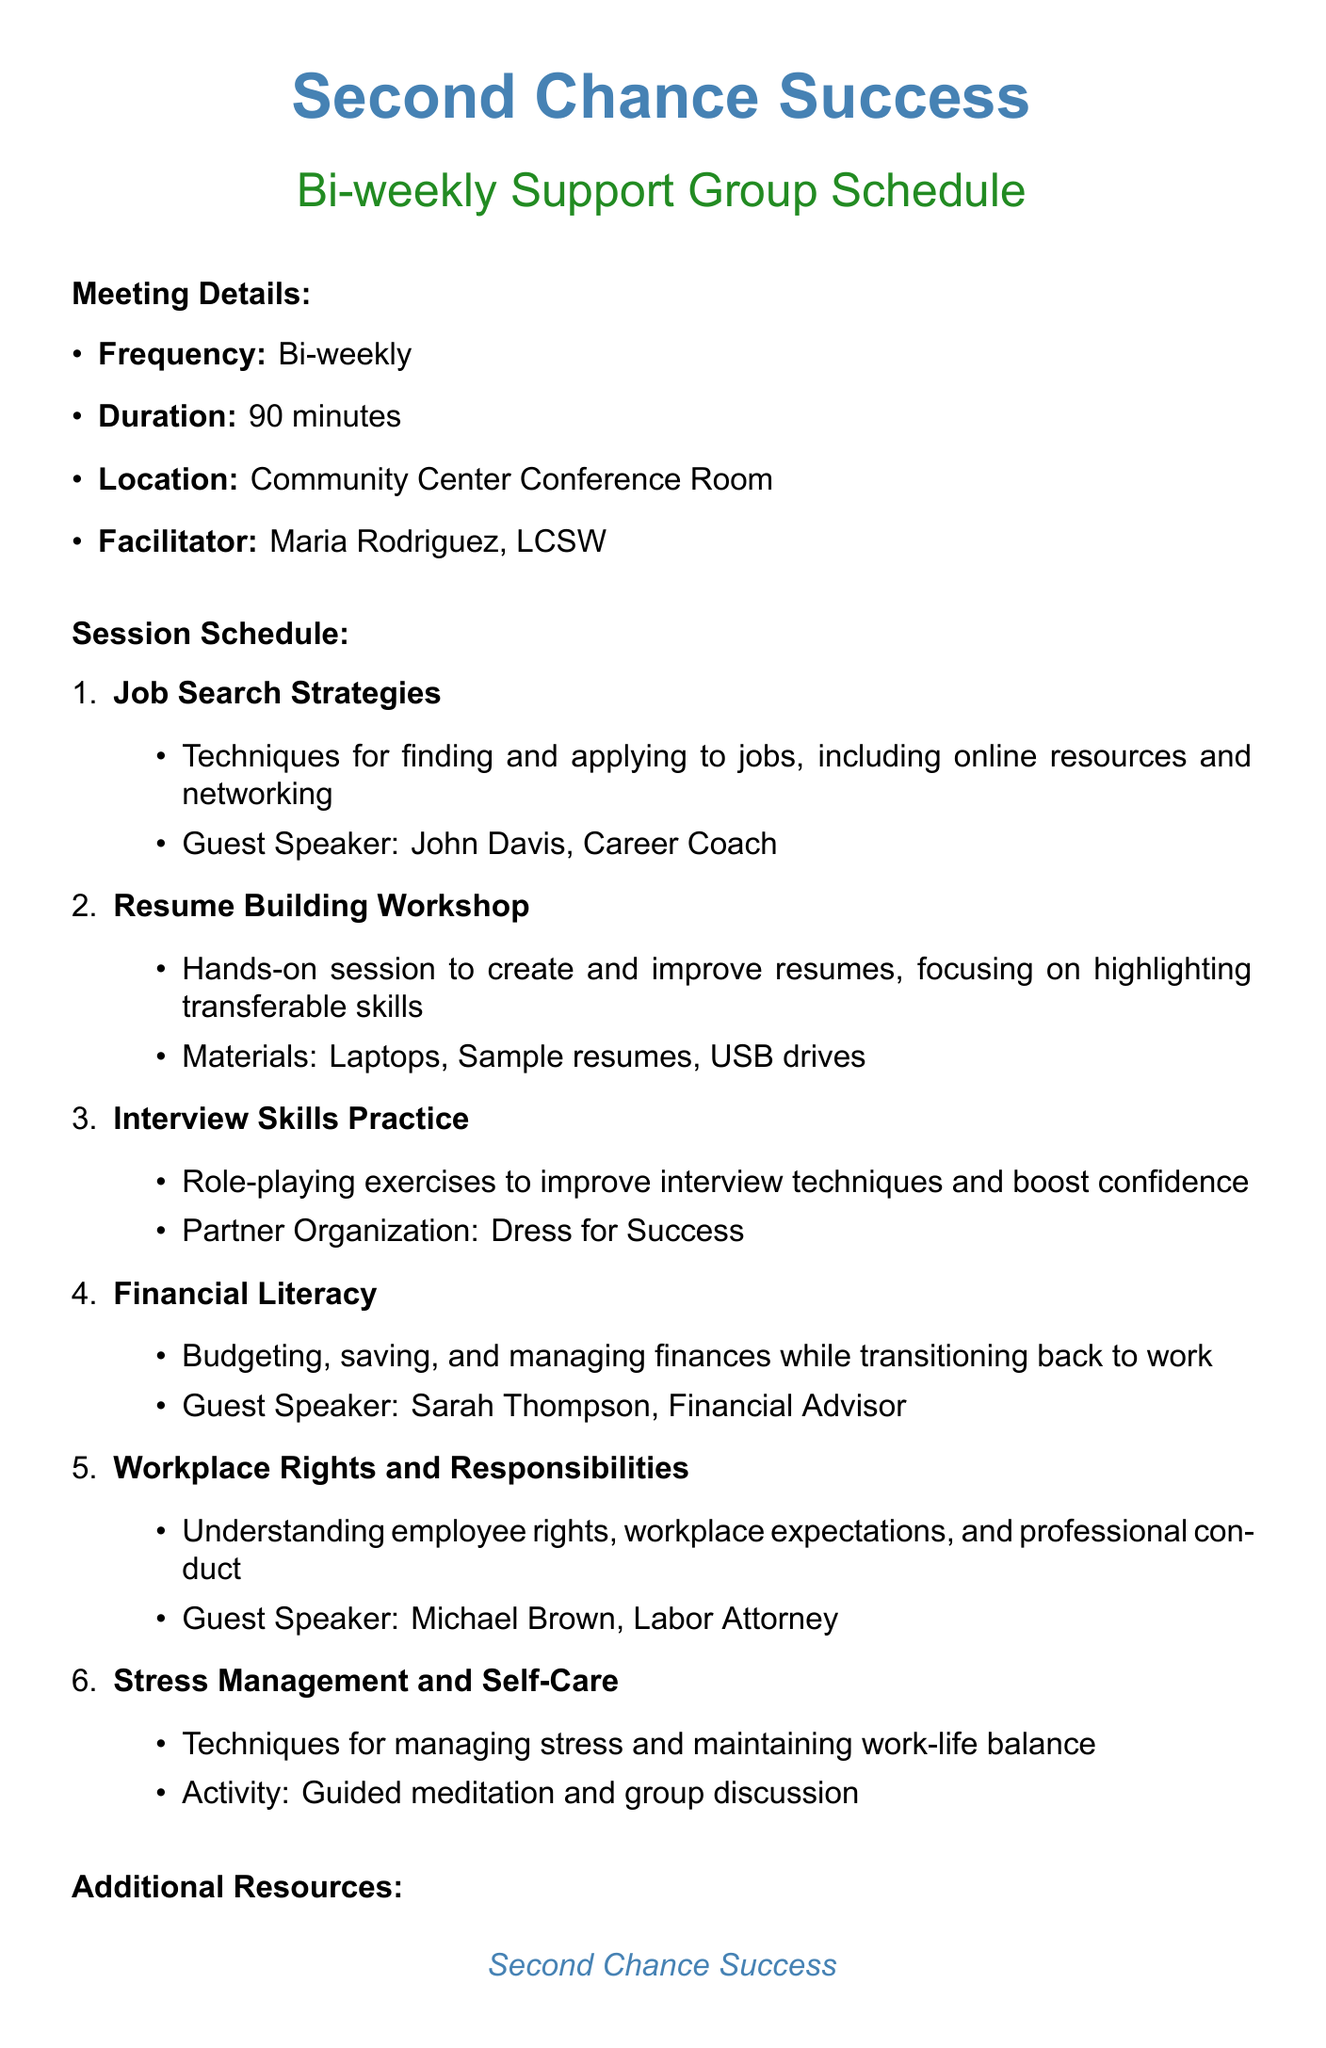What is the name of the support group? The name of the support group is explicitly stated in the document as 'Second Chance Success.'
Answer: Second Chance Success Who is the facilitator of the meetings? The facilitator of the meetings is mentioned in the document as 'Maria Rodriguez, LCSW.'
Answer: Maria Rodriguez, LCSW What is the duration of each meeting? The duration of each meeting is provided in the document as 90 minutes.
Answer: 90 minutes What type of workshop focuses on creating and improving resumes? The document specifies that the 'Resume Building Workshop' focuses on hands-on sessions related to resumes.
Answer: Resume Building Workshop Which organization partners with the group for role-playing exercises? The document states that 'Dress for Success' is the partner organization for interview skills practice.
Answer: Dress for Success What is one of the guest speakers discussing in the financial literacy session? The document lists 'Sarah Thompson, Financial Advisor' as the guest speaker for Financial Literacy session topics.
Answer: Sarah Thompson, Financial Advisor How often are the support group meetings held? The frequency of the meetings is stated in the document as bi-weekly.
Answer: Bi-weekly What type of assistance is available for transportation? The document mentions that 'bus passes' are available upon request as transportation assistance.
Answer: Bus passes What is required for childcare services during meetings? The document indicates that a reservation is required for childcare services provided by the YMCA Childcare Center.
Answer: Reservation required 